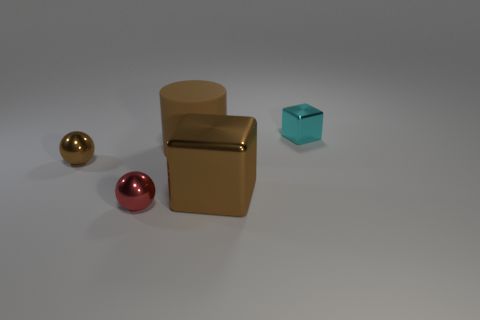Add 4 big rubber cylinders. How many objects exist? 9 Subtract all cylinders. How many objects are left? 4 Add 3 big brown metallic objects. How many big brown metallic objects exist? 4 Subtract 1 cyan blocks. How many objects are left? 4 Subtract all large yellow objects. Subtract all cyan objects. How many objects are left? 4 Add 5 large cylinders. How many large cylinders are left? 6 